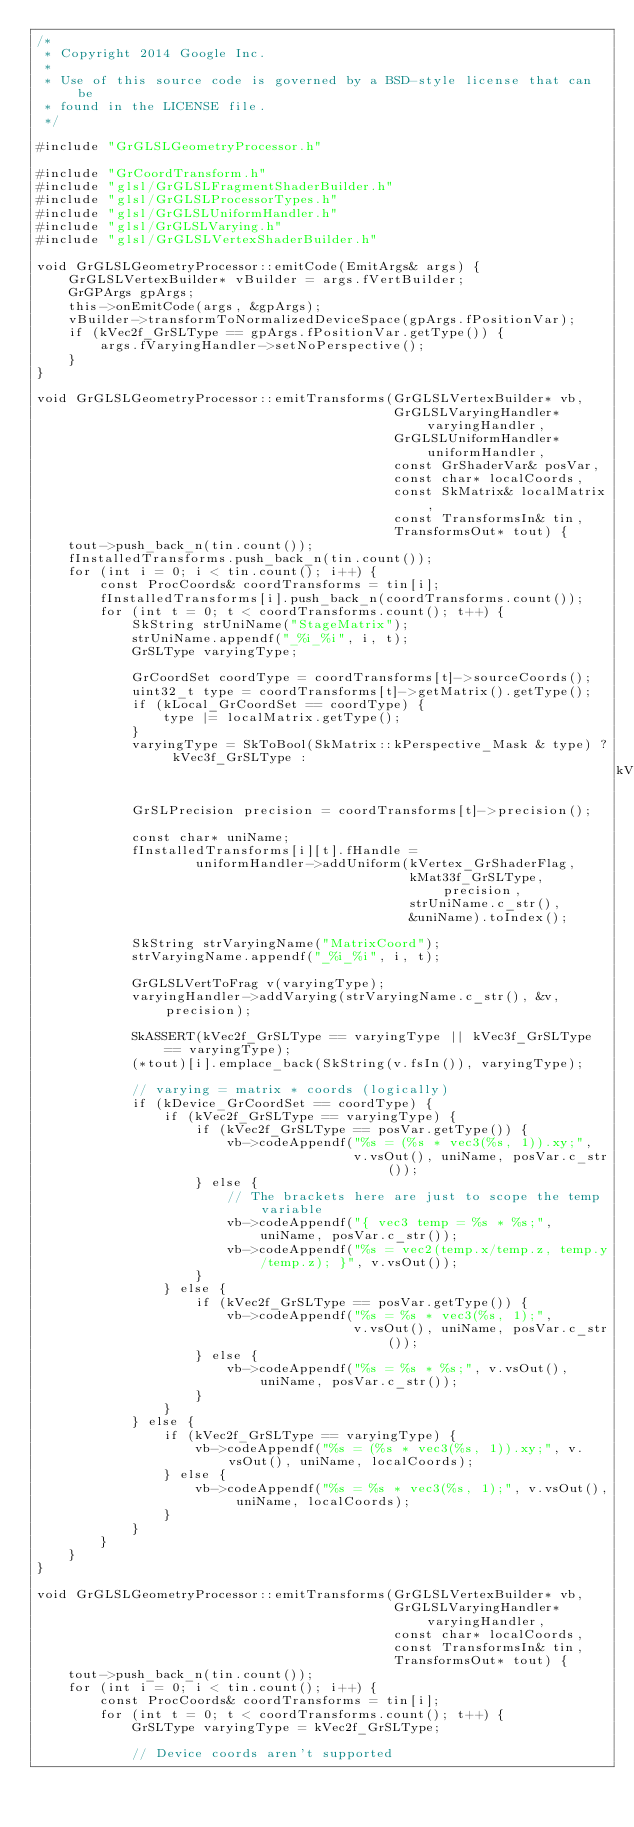<code> <loc_0><loc_0><loc_500><loc_500><_C++_>/*
 * Copyright 2014 Google Inc.
 *
 * Use of this source code is governed by a BSD-style license that can be
 * found in the LICENSE file.
 */

#include "GrGLSLGeometryProcessor.h"

#include "GrCoordTransform.h"
#include "glsl/GrGLSLFragmentShaderBuilder.h"
#include "glsl/GrGLSLProcessorTypes.h"
#include "glsl/GrGLSLUniformHandler.h"
#include "glsl/GrGLSLVarying.h"
#include "glsl/GrGLSLVertexShaderBuilder.h"

void GrGLSLGeometryProcessor::emitCode(EmitArgs& args) {
    GrGLSLVertexBuilder* vBuilder = args.fVertBuilder;
    GrGPArgs gpArgs;
    this->onEmitCode(args, &gpArgs);
    vBuilder->transformToNormalizedDeviceSpace(gpArgs.fPositionVar);
    if (kVec2f_GrSLType == gpArgs.fPositionVar.getType()) {
        args.fVaryingHandler->setNoPerspective();
    }
}

void GrGLSLGeometryProcessor::emitTransforms(GrGLSLVertexBuilder* vb,
                                             GrGLSLVaryingHandler* varyingHandler,
                                             GrGLSLUniformHandler* uniformHandler,
                                             const GrShaderVar& posVar,
                                             const char* localCoords,
                                             const SkMatrix& localMatrix,
                                             const TransformsIn& tin,
                                             TransformsOut* tout) {
    tout->push_back_n(tin.count());
    fInstalledTransforms.push_back_n(tin.count());
    for (int i = 0; i < tin.count(); i++) {
        const ProcCoords& coordTransforms = tin[i];
        fInstalledTransforms[i].push_back_n(coordTransforms.count());
        for (int t = 0; t < coordTransforms.count(); t++) {
            SkString strUniName("StageMatrix");
            strUniName.appendf("_%i_%i", i, t);
            GrSLType varyingType;

            GrCoordSet coordType = coordTransforms[t]->sourceCoords();
            uint32_t type = coordTransforms[t]->getMatrix().getType();
            if (kLocal_GrCoordSet == coordType) {
                type |= localMatrix.getType();
            }
            varyingType = SkToBool(SkMatrix::kPerspective_Mask & type) ? kVec3f_GrSLType :
                                                                         kVec2f_GrSLType;
            GrSLPrecision precision = coordTransforms[t]->precision();

            const char* uniName;
            fInstalledTransforms[i][t].fHandle =
                    uniformHandler->addUniform(kVertex_GrShaderFlag,
                                               kMat33f_GrSLType, precision,
                                               strUniName.c_str(),
                                               &uniName).toIndex();

            SkString strVaryingName("MatrixCoord");
            strVaryingName.appendf("_%i_%i", i, t);

            GrGLSLVertToFrag v(varyingType);
            varyingHandler->addVarying(strVaryingName.c_str(), &v, precision);

            SkASSERT(kVec2f_GrSLType == varyingType || kVec3f_GrSLType == varyingType);
            (*tout)[i].emplace_back(SkString(v.fsIn()), varyingType);

            // varying = matrix * coords (logically)
            if (kDevice_GrCoordSet == coordType) {
                if (kVec2f_GrSLType == varyingType) {
                    if (kVec2f_GrSLType == posVar.getType()) {
                        vb->codeAppendf("%s = (%s * vec3(%s, 1)).xy;",
                                        v.vsOut(), uniName, posVar.c_str());
                    } else {
                        // The brackets here are just to scope the temp variable
                        vb->codeAppendf("{ vec3 temp = %s * %s;", uniName, posVar.c_str());
                        vb->codeAppendf("%s = vec2(temp.x/temp.z, temp.y/temp.z); }", v.vsOut());
                    }
                } else {
                    if (kVec2f_GrSLType == posVar.getType()) {
                        vb->codeAppendf("%s = %s * vec3(%s, 1);",
                                        v.vsOut(), uniName, posVar.c_str());
                    } else {
                        vb->codeAppendf("%s = %s * %s;", v.vsOut(), uniName, posVar.c_str());
                    }
                }
            } else {
                if (kVec2f_GrSLType == varyingType) {
                    vb->codeAppendf("%s = (%s * vec3(%s, 1)).xy;", v.vsOut(), uniName, localCoords);
                } else {
                    vb->codeAppendf("%s = %s * vec3(%s, 1);", v.vsOut(), uniName, localCoords);
                }
            }
        }
    }
}

void GrGLSLGeometryProcessor::emitTransforms(GrGLSLVertexBuilder* vb,
                                             GrGLSLVaryingHandler* varyingHandler,
                                             const char* localCoords,
                                             const TransformsIn& tin,
                                             TransformsOut* tout) {
    tout->push_back_n(tin.count());
    for (int i = 0; i < tin.count(); i++) {
        const ProcCoords& coordTransforms = tin[i];
        for (int t = 0; t < coordTransforms.count(); t++) {
            GrSLType varyingType = kVec2f_GrSLType;

            // Device coords aren't supported</code> 